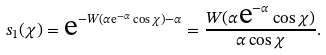Convert formula to latex. <formula><loc_0><loc_0><loc_500><loc_500>s _ { 1 } ( \chi ) = \text  e^{-W(\alpha\text  e^{-\alpha}\cos\chi)-\alpha} = \frac { W ( \alpha \text  e^{-\alpha} \cos \chi ) } { \alpha \cos \chi } .</formula> 